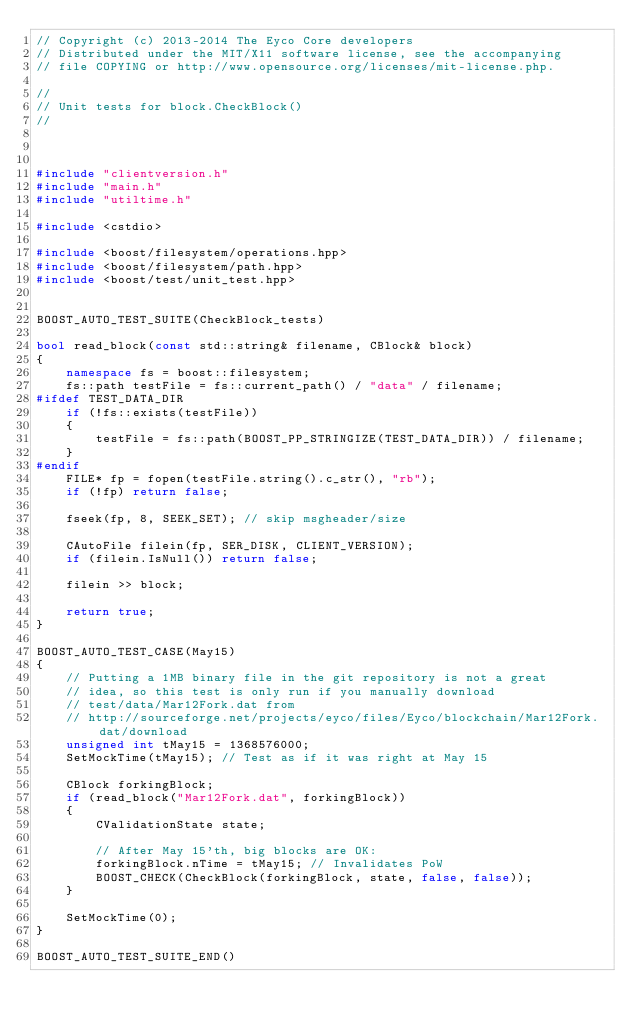<code> <loc_0><loc_0><loc_500><loc_500><_C++_>// Copyright (c) 2013-2014 The Eyco Core developers
// Distributed under the MIT/X11 software license, see the accompanying
// file COPYING or http://www.opensource.org/licenses/mit-license.php.

//
// Unit tests for block.CheckBlock()
//



#include "clientversion.h"
#include "main.h"
#include "utiltime.h"

#include <cstdio>

#include <boost/filesystem/operations.hpp>
#include <boost/filesystem/path.hpp>
#include <boost/test/unit_test.hpp>


BOOST_AUTO_TEST_SUITE(CheckBlock_tests)

bool read_block(const std::string& filename, CBlock& block)
{
    namespace fs = boost::filesystem;
    fs::path testFile = fs::current_path() / "data" / filename;
#ifdef TEST_DATA_DIR
    if (!fs::exists(testFile))
    {
        testFile = fs::path(BOOST_PP_STRINGIZE(TEST_DATA_DIR)) / filename;
    }
#endif
    FILE* fp = fopen(testFile.string().c_str(), "rb");
    if (!fp) return false;

    fseek(fp, 8, SEEK_SET); // skip msgheader/size

    CAutoFile filein(fp, SER_DISK, CLIENT_VERSION);
    if (filein.IsNull()) return false;

    filein >> block;

    return true;
}

BOOST_AUTO_TEST_CASE(May15)
{
    // Putting a 1MB binary file in the git repository is not a great
    // idea, so this test is only run if you manually download
    // test/data/Mar12Fork.dat from
    // http://sourceforge.net/projects/eyco/files/Eyco/blockchain/Mar12Fork.dat/download
    unsigned int tMay15 = 1368576000;
    SetMockTime(tMay15); // Test as if it was right at May 15

    CBlock forkingBlock;
    if (read_block("Mar12Fork.dat", forkingBlock))
    {
        CValidationState state;

        // After May 15'th, big blocks are OK:
        forkingBlock.nTime = tMay15; // Invalidates PoW
        BOOST_CHECK(CheckBlock(forkingBlock, state, false, false));
    }

    SetMockTime(0);
}

BOOST_AUTO_TEST_SUITE_END()
</code> 